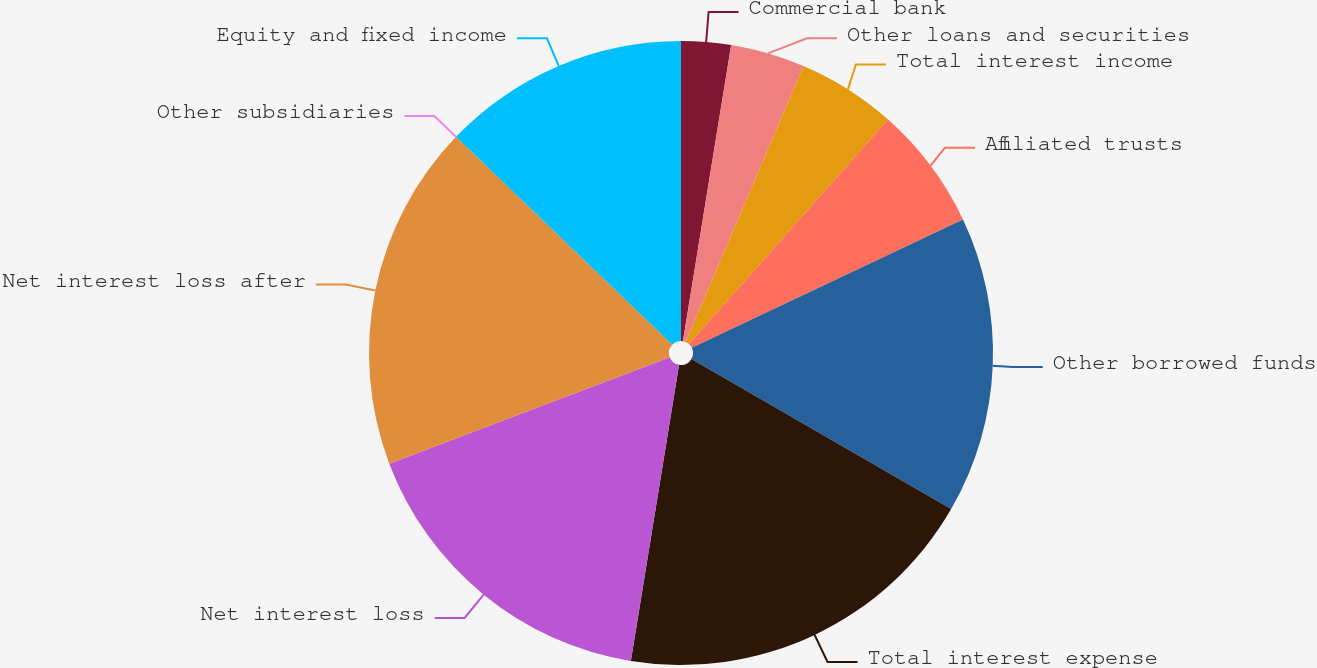Convert chart. <chart><loc_0><loc_0><loc_500><loc_500><pie_chart><fcel>Commercial bank<fcel>Other loans and securities<fcel>Total interest income<fcel>Affiliated trusts<fcel>Other borrowed funds<fcel>Total interest expense<fcel>Net interest loss<fcel>Net interest loss after<fcel>Other subsidiaries<fcel>Equity and fixed income<nl><fcel>2.57%<fcel>3.85%<fcel>5.13%<fcel>6.41%<fcel>15.38%<fcel>19.23%<fcel>16.66%<fcel>17.95%<fcel>0.0%<fcel>12.82%<nl></chart> 